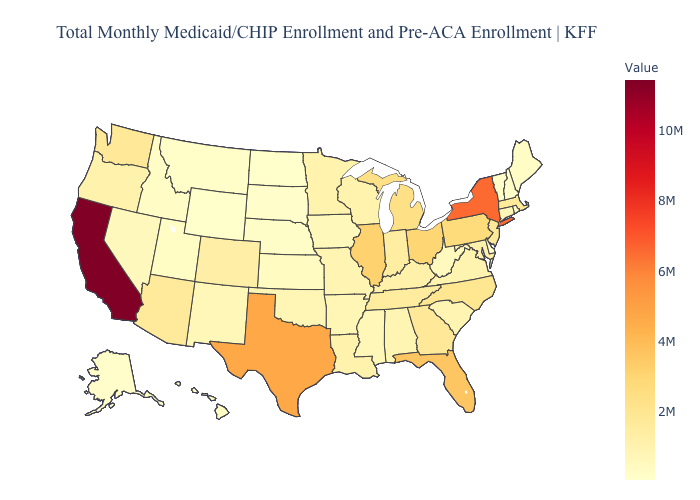Which states have the lowest value in the South?
Keep it brief. Delaware. Among the states that border Delaware , does Maryland have the lowest value?
Answer briefly. Yes. Does Indiana have a higher value than Idaho?
Short answer required. Yes. Among the states that border Texas , which have the lowest value?
Give a very brief answer. New Mexico. 